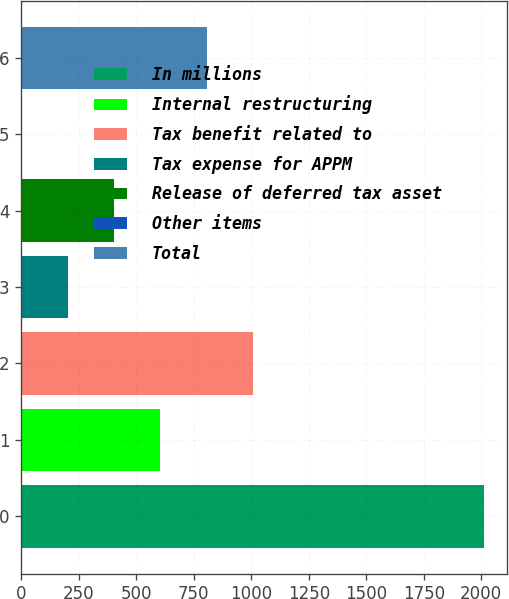Convert chart to OTSL. <chart><loc_0><loc_0><loc_500><loc_500><bar_chart><fcel>In millions<fcel>Internal restructuring<fcel>Tax benefit related to<fcel>Tax expense for APPM<fcel>Release of deferred tax asset<fcel>Other items<fcel>Total<nl><fcel>2011<fcel>604.7<fcel>1006.5<fcel>202.9<fcel>403.8<fcel>2<fcel>805.6<nl></chart> 